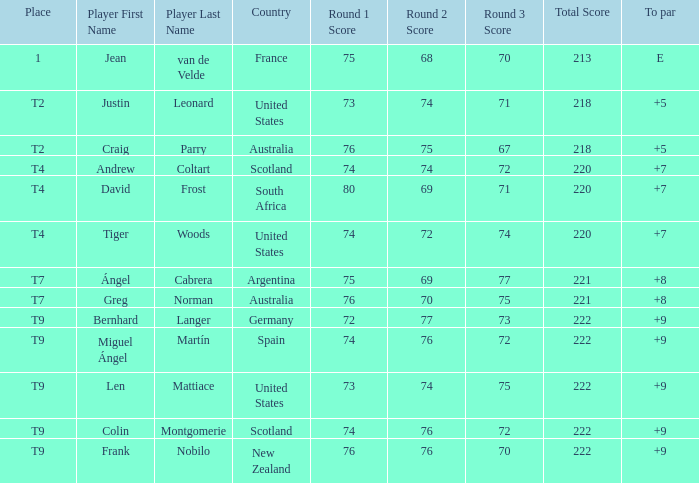What is the position number for the player with a to par score of 'e'? 1.0. 